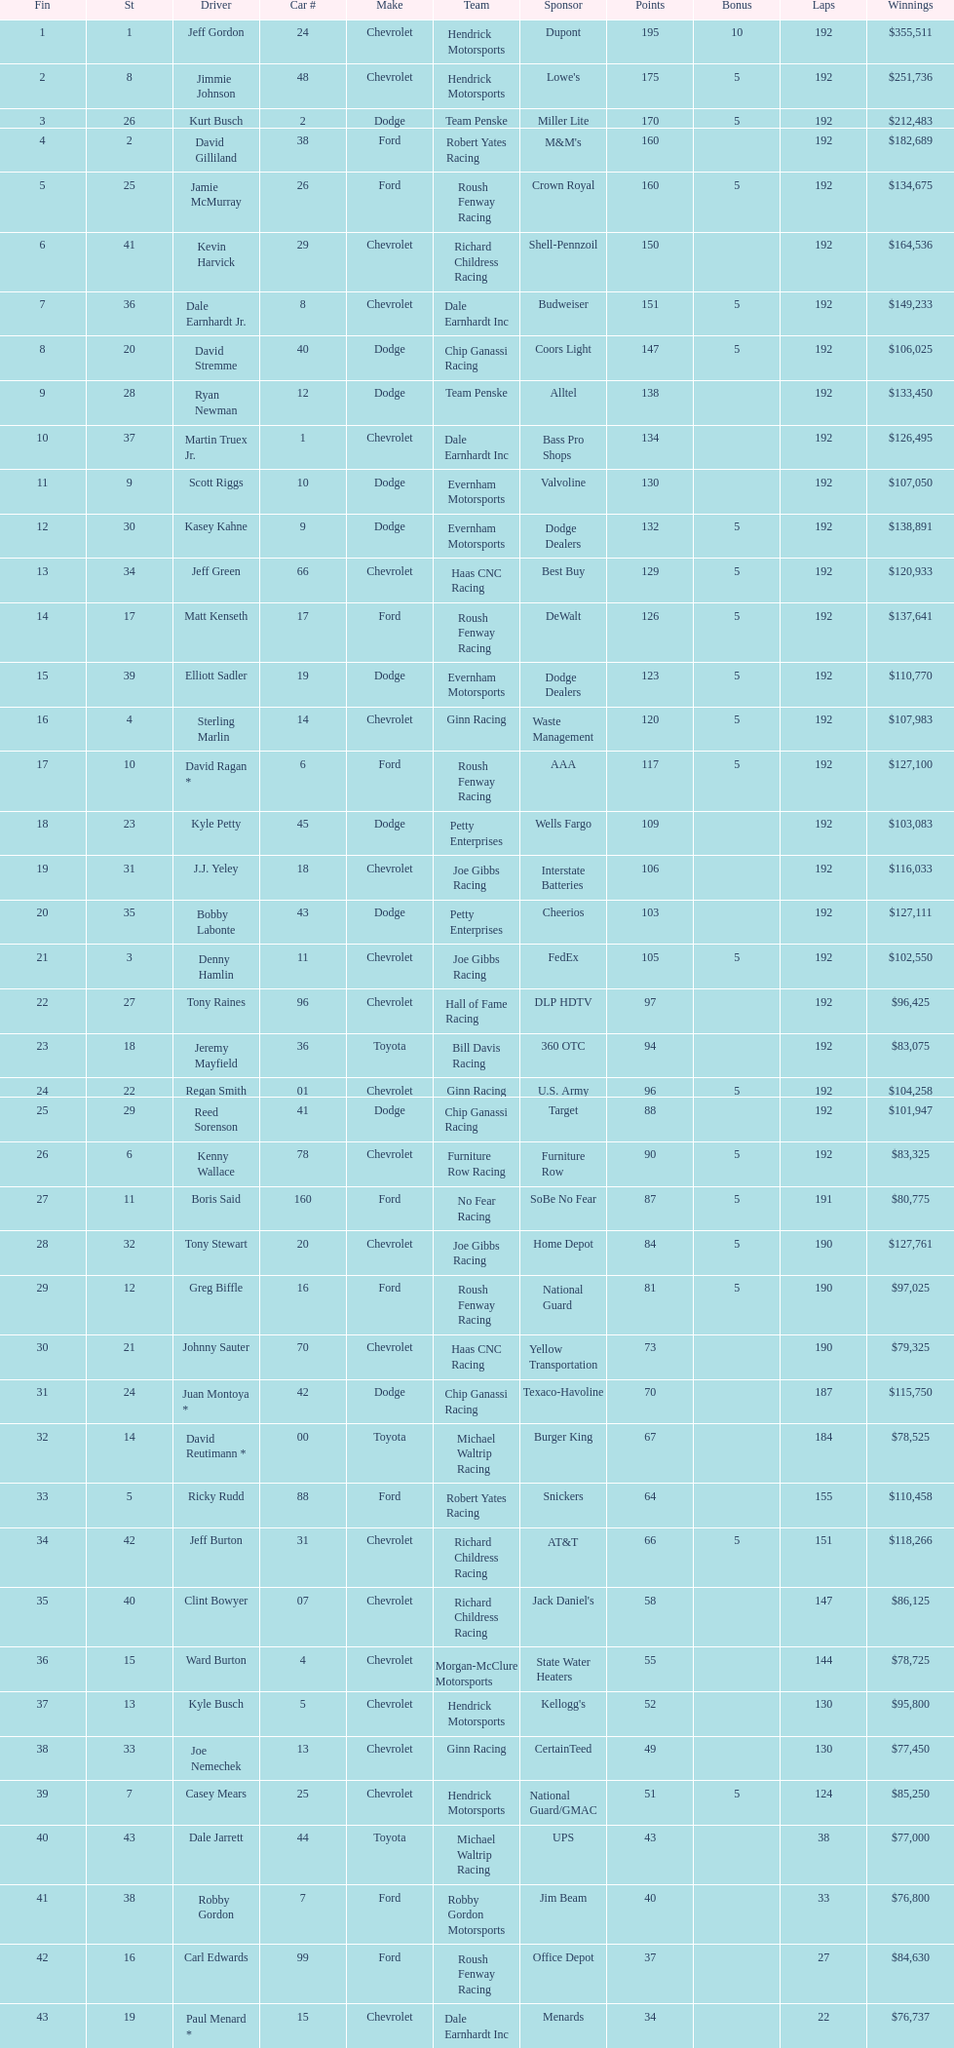Parse the full table. {'header': ['Fin', 'St', 'Driver', 'Car #', 'Make', 'Team', 'Sponsor', 'Points', 'Bonus', 'Laps', 'Winnings'], 'rows': [['1', '1', 'Jeff Gordon', '24', 'Chevrolet', 'Hendrick Motorsports', 'Dupont', '195', '10', '192', '$355,511'], ['2', '8', 'Jimmie Johnson', '48', 'Chevrolet', 'Hendrick Motorsports', "Lowe's", '175', '5', '192', '$251,736'], ['3', '26', 'Kurt Busch', '2', 'Dodge', 'Team Penske', 'Miller Lite', '170', '5', '192', '$212,483'], ['4', '2', 'David Gilliland', '38', 'Ford', 'Robert Yates Racing', "M&M's", '160', '', '192', '$182,689'], ['5', '25', 'Jamie McMurray', '26', 'Ford', 'Roush Fenway Racing', 'Crown Royal', '160', '5', '192', '$134,675'], ['6', '41', 'Kevin Harvick', '29', 'Chevrolet', 'Richard Childress Racing', 'Shell-Pennzoil', '150', '', '192', '$164,536'], ['7', '36', 'Dale Earnhardt Jr.', '8', 'Chevrolet', 'Dale Earnhardt Inc', 'Budweiser', '151', '5', '192', '$149,233'], ['8', '20', 'David Stremme', '40', 'Dodge', 'Chip Ganassi Racing', 'Coors Light', '147', '5', '192', '$106,025'], ['9', '28', 'Ryan Newman', '12', 'Dodge', 'Team Penske', 'Alltel', '138', '', '192', '$133,450'], ['10', '37', 'Martin Truex Jr.', '1', 'Chevrolet', 'Dale Earnhardt Inc', 'Bass Pro Shops', '134', '', '192', '$126,495'], ['11', '9', 'Scott Riggs', '10', 'Dodge', 'Evernham Motorsports', 'Valvoline', '130', '', '192', '$107,050'], ['12', '30', 'Kasey Kahne', '9', 'Dodge', 'Evernham Motorsports', 'Dodge Dealers', '132', '5', '192', '$138,891'], ['13', '34', 'Jeff Green', '66', 'Chevrolet', 'Haas CNC Racing', 'Best Buy', '129', '5', '192', '$120,933'], ['14', '17', 'Matt Kenseth', '17', 'Ford', 'Roush Fenway Racing', 'DeWalt', '126', '5', '192', '$137,641'], ['15', '39', 'Elliott Sadler', '19', 'Dodge', 'Evernham Motorsports', 'Dodge Dealers', '123', '5', '192', '$110,770'], ['16', '4', 'Sterling Marlin', '14', 'Chevrolet', 'Ginn Racing', 'Waste Management', '120', '5', '192', '$107,983'], ['17', '10', 'David Ragan *', '6', 'Ford', 'Roush Fenway Racing', 'AAA', '117', '5', '192', '$127,100'], ['18', '23', 'Kyle Petty', '45', 'Dodge', 'Petty Enterprises', 'Wells Fargo', '109', '', '192', '$103,083'], ['19', '31', 'J.J. Yeley', '18', 'Chevrolet', 'Joe Gibbs Racing', 'Interstate Batteries', '106', '', '192', '$116,033'], ['20', '35', 'Bobby Labonte', '43', 'Dodge', 'Petty Enterprises', 'Cheerios', '103', '', '192', '$127,111'], ['21', '3', 'Denny Hamlin', '11', 'Chevrolet', 'Joe Gibbs Racing', 'FedEx', '105', '5', '192', '$102,550'], ['22', '27', 'Tony Raines', '96', 'Chevrolet', 'Hall of Fame Racing', 'DLP HDTV', '97', '', '192', '$96,425'], ['23', '18', 'Jeremy Mayfield', '36', 'Toyota', 'Bill Davis Racing', '360 OTC', '94', '', '192', '$83,075'], ['24', '22', 'Regan Smith', '01', 'Chevrolet', 'Ginn Racing', 'U.S. Army', '96', '5', '192', '$104,258'], ['25', '29', 'Reed Sorenson', '41', 'Dodge', 'Chip Ganassi Racing', 'Target', '88', '', '192', '$101,947'], ['26', '6', 'Kenny Wallace', '78', 'Chevrolet', 'Furniture Row Racing', 'Furniture Row', '90', '5', '192', '$83,325'], ['27', '11', 'Boris Said', '160', 'Ford', 'No Fear Racing', 'SoBe No Fear', '87', '5', '191', '$80,775'], ['28', '32', 'Tony Stewart', '20', 'Chevrolet', 'Joe Gibbs Racing', 'Home Depot', '84', '5', '190', '$127,761'], ['29', '12', 'Greg Biffle', '16', 'Ford', 'Roush Fenway Racing', 'National Guard', '81', '5', '190', '$97,025'], ['30', '21', 'Johnny Sauter', '70', 'Chevrolet', 'Haas CNC Racing', 'Yellow Transportation', '73', '', '190', '$79,325'], ['31', '24', 'Juan Montoya *', '42', 'Dodge', 'Chip Ganassi Racing', 'Texaco-Havoline', '70', '', '187', '$115,750'], ['32', '14', 'David Reutimann *', '00', 'Toyota', 'Michael Waltrip Racing', 'Burger King', '67', '', '184', '$78,525'], ['33', '5', 'Ricky Rudd', '88', 'Ford', 'Robert Yates Racing', 'Snickers', '64', '', '155', '$110,458'], ['34', '42', 'Jeff Burton', '31', 'Chevrolet', 'Richard Childress Racing', 'AT&T', '66', '5', '151', '$118,266'], ['35', '40', 'Clint Bowyer', '07', 'Chevrolet', 'Richard Childress Racing', "Jack Daniel's", '58', '', '147', '$86,125'], ['36', '15', 'Ward Burton', '4', 'Chevrolet', 'Morgan-McClure Motorsports', 'State Water Heaters', '55', '', '144', '$78,725'], ['37', '13', 'Kyle Busch', '5', 'Chevrolet', 'Hendrick Motorsports', "Kellogg's", '52', '', '130', '$95,800'], ['38', '33', 'Joe Nemechek', '13', 'Chevrolet', 'Ginn Racing', 'CertainTeed', '49', '', '130', '$77,450'], ['39', '7', 'Casey Mears', '25', 'Chevrolet', 'Hendrick Motorsports', 'National Guard/GMAC', '51', '5', '124', '$85,250'], ['40', '43', 'Dale Jarrett', '44', 'Toyota', 'Michael Waltrip Racing', 'UPS', '43', '', '38', '$77,000'], ['41', '38', 'Robby Gordon', '7', 'Ford', 'Robby Gordon Motorsports', 'Jim Beam', '40', '', '33', '$76,800'], ['42', '16', 'Carl Edwards', '99', 'Ford', 'Roush Fenway Racing', 'Office Depot', '37', '', '27', '$84,630'], ['43', '19', 'Paul Menard *', '15', 'Chevrolet', 'Dale Earnhardt Inc', 'Menards', '34', '', '22', '$76,737']]} What was the make of both jeff gordon's and jimmie johnson's race car? Chevrolet. 